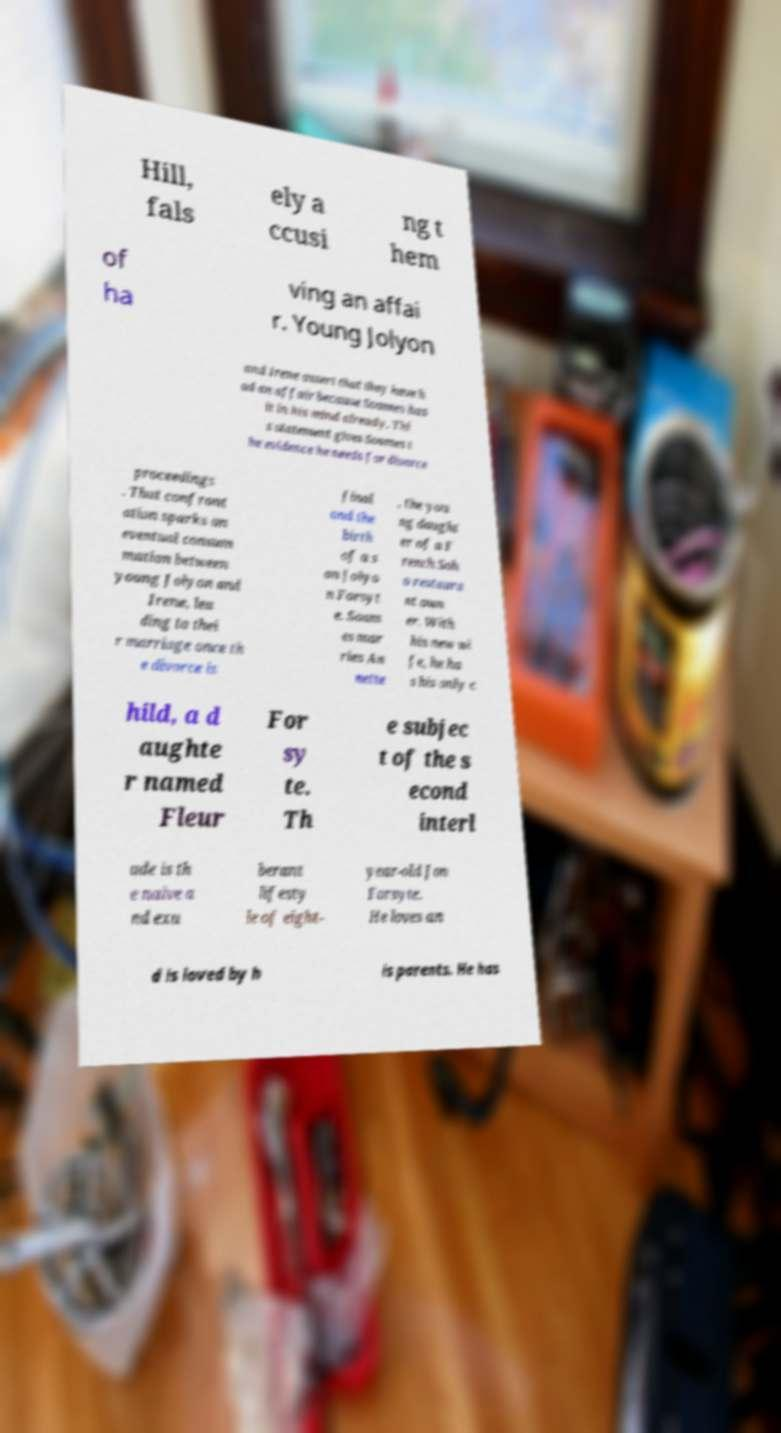What messages or text are displayed in this image? I need them in a readable, typed format. Hill, fals ely a ccusi ng t hem of ha ving an affai r. Young Jolyon and Irene assert that they have h ad an affair because Soames has it in his mind already. Thi s statement gives Soames t he evidence he needs for divorce proceedings . That confront ation sparks an eventual consum mation between young Jolyon and Irene, lea ding to thei r marriage once th e divorce is final and the birth of a s on Jolyo n Forsyt e. Soam es mar ries An nette , the you ng daught er of a F rench Soh o restaura nt own er. With his new wi fe, he ha s his only c hild, a d aughte r named Fleur For sy te. Th e subjec t of the s econd interl ude is th e naive a nd exu berant lifesty le of eight- year-old Jon Forsyte. He loves an d is loved by h is parents. He has 